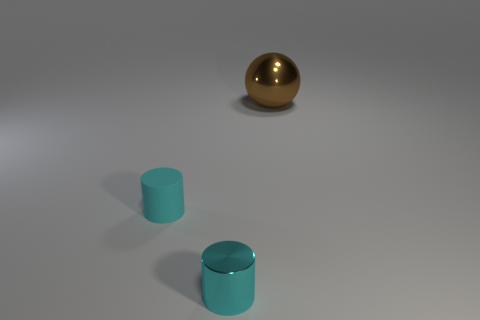Add 2 small blue cylinders. How many objects exist? 5 Subtract 2 cylinders. How many cylinders are left? 0 Add 3 large gray spheres. How many large gray spheres exist? 3 Subtract 0 cyan cubes. How many objects are left? 3 Subtract all cylinders. How many objects are left? 1 Subtract all gray cylinders. Subtract all gray blocks. How many cylinders are left? 2 Subtract all small cyan metallic cylinders. Subtract all big brown balls. How many objects are left? 1 Add 2 metal things. How many metal things are left? 4 